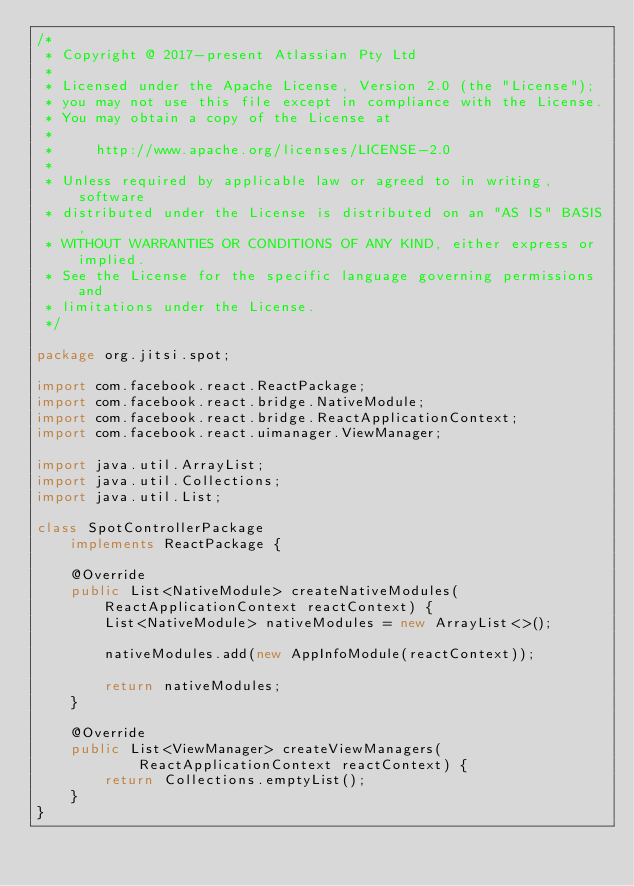Convert code to text. <code><loc_0><loc_0><loc_500><loc_500><_Java_>/*
 * Copyright @ 2017-present Atlassian Pty Ltd
 *
 * Licensed under the Apache License, Version 2.0 (the "License");
 * you may not use this file except in compliance with the License.
 * You may obtain a copy of the License at
 *
 *     http://www.apache.org/licenses/LICENSE-2.0
 *
 * Unless required by applicable law or agreed to in writing, software
 * distributed under the License is distributed on an "AS IS" BASIS,
 * WITHOUT WARRANTIES OR CONDITIONS OF ANY KIND, either express or implied.
 * See the License for the specific language governing permissions and
 * limitations under the License.
 */

package org.jitsi.spot;

import com.facebook.react.ReactPackage;
import com.facebook.react.bridge.NativeModule;
import com.facebook.react.bridge.ReactApplicationContext;
import com.facebook.react.uimanager.ViewManager;

import java.util.ArrayList;
import java.util.Collections;
import java.util.List;

class SpotControllerPackage
    implements ReactPackage {

    @Override
    public List<NativeModule> createNativeModules(ReactApplicationContext reactContext) {
        List<NativeModule> nativeModules = new ArrayList<>();

        nativeModules.add(new AppInfoModule(reactContext));

        return nativeModules;
    }

    @Override
    public List<ViewManager> createViewManagers(
            ReactApplicationContext reactContext) {
        return Collections.emptyList();
    }
}
</code> 